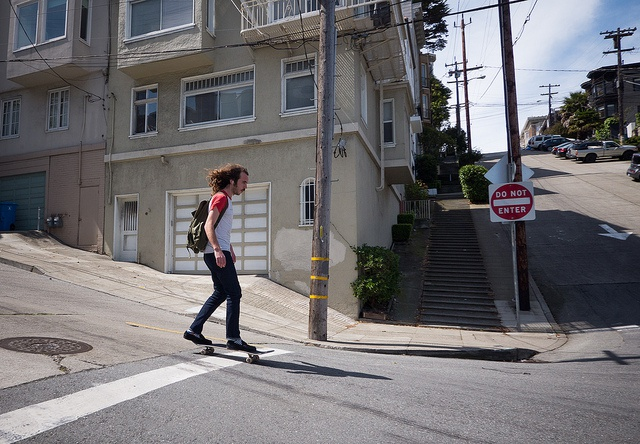Describe the objects in this image and their specific colors. I can see people in black, gray, darkgray, and maroon tones, backpack in black, gray, and darkgray tones, truck in black and gray tones, skateboard in black, darkgray, gray, and white tones, and car in black, gray, and darkgray tones in this image. 